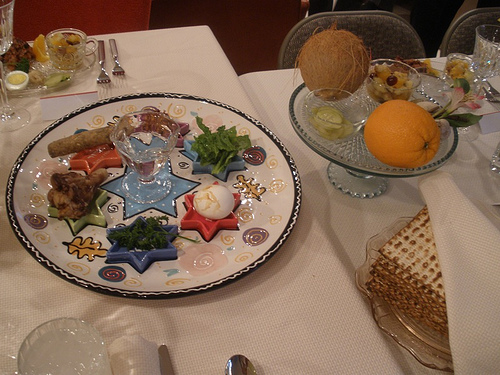Imagine this meal is presented in a high-end restaurant. Describe the atmosphere and the service. At a high-end restaurant, this meal would be presented with great elegance. The atmosphere would be refined, with soft lighting, elegant table settings, and attentive service. Waitstaff would be impeccably dressed, offering knowledgeable suggestions about the meal and ensuring every detail is perfect. What could the chef's inspiration be for this particular presentation? The chef might be inspired by traditional cultural celebrations, aiming to create an authentic and nostalgic experience for diners. The intricate arrangement of foods and the use of symbolic items like matzo and the Seder plate suggest a deep respect for heritage and ritual. Craft a dialogue where the chef explains the significance of each item on the plate to a curious diner. Chef: Welcome to our special Passover Seder dinner. Each item on this plate has a unique significance. The hard-boiled egg symbolizes the festival sacrifice offered in the Temple in Jerusalem. The bitter herbs remind us of the bitterness of slavery. Dingy greens like parsley represent the initial flourishing of the Israelites in Egypt. The orange is a modern addition, symbolizing inclusivity and the recognition of marginalized groups. The matzo, or unleavened bread, reflects the haste in which the Israelites left Egypt, not allowing time for the dough to rise. 